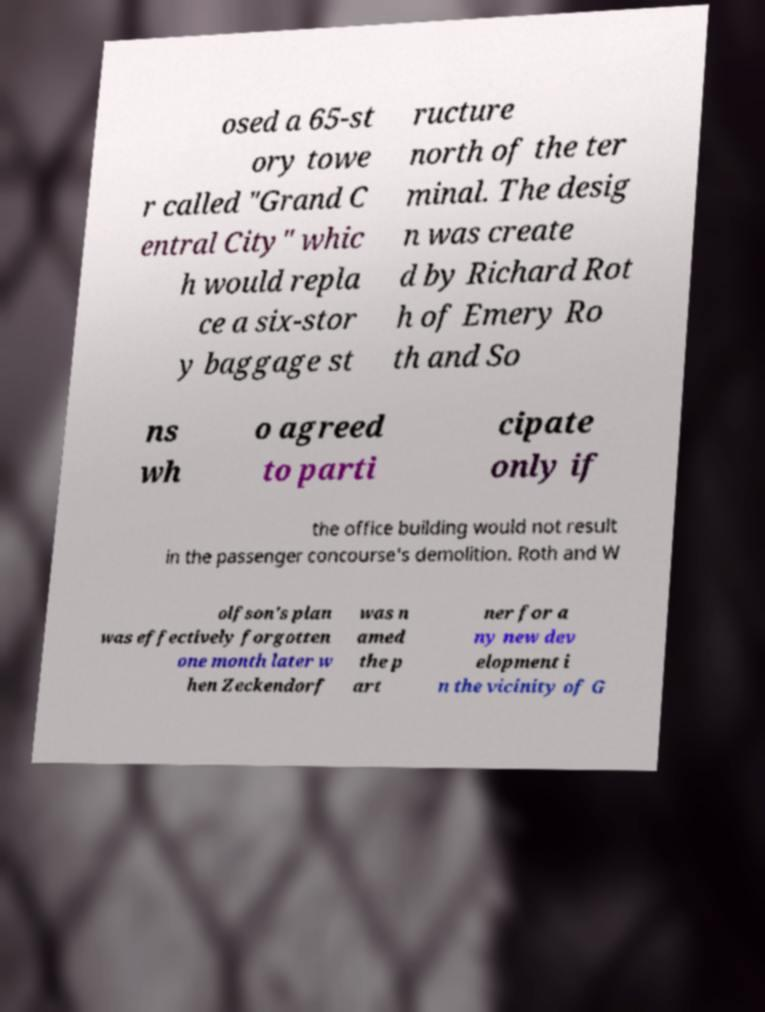Can you read and provide the text displayed in the image?This photo seems to have some interesting text. Can you extract and type it out for me? osed a 65-st ory towe r called "Grand C entral City" whic h would repla ce a six-stor y baggage st ructure north of the ter minal. The desig n was create d by Richard Rot h of Emery Ro th and So ns wh o agreed to parti cipate only if the office building would not result in the passenger concourse's demolition. Roth and W olfson's plan was effectively forgotten one month later w hen Zeckendorf was n amed the p art ner for a ny new dev elopment i n the vicinity of G 